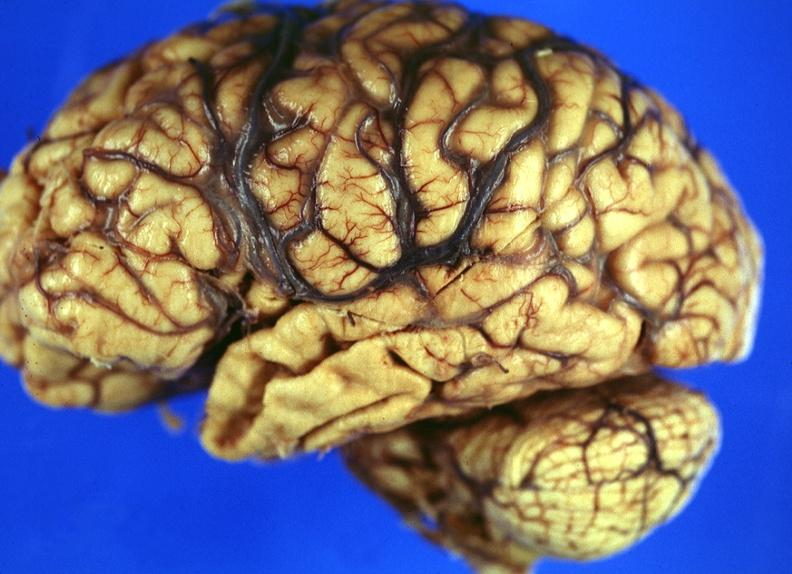does gaucher cell show brain, frontal lobe atrophy, pick 's disease?
Answer the question using a single word or phrase. No 